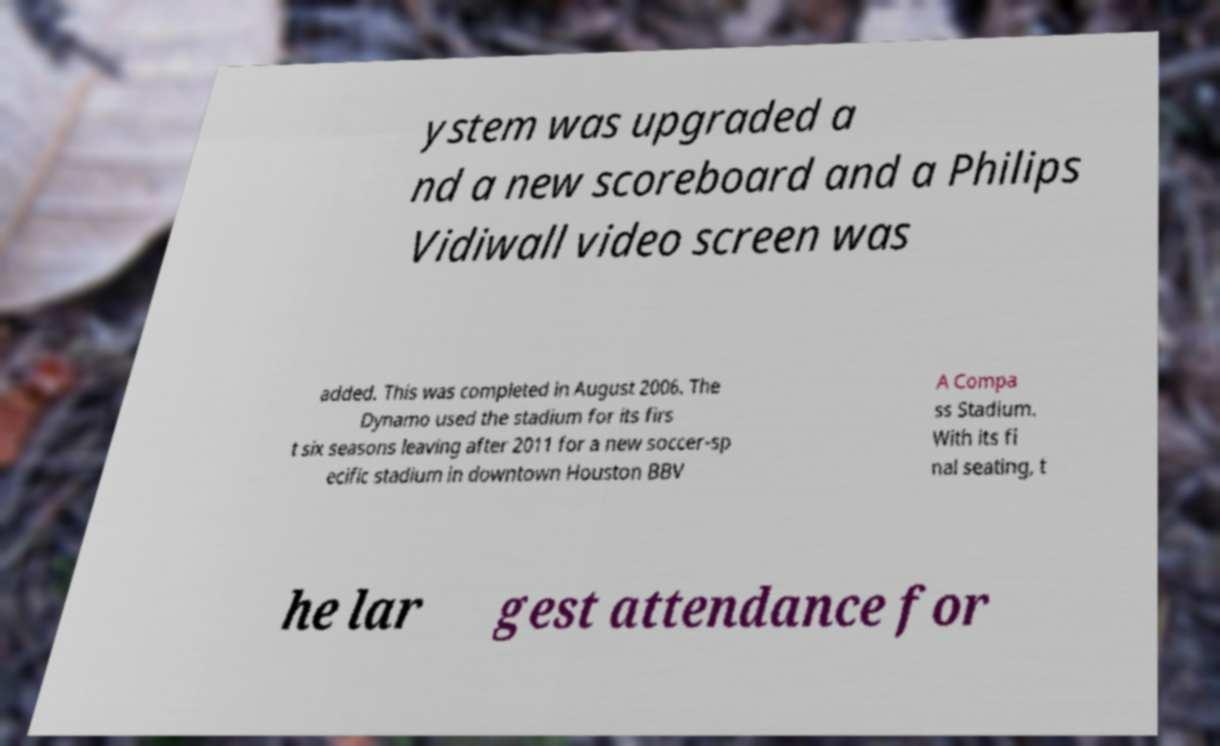Can you read and provide the text displayed in the image?This photo seems to have some interesting text. Can you extract and type it out for me? ystem was upgraded a nd a new scoreboard and a Philips Vidiwall video screen was added. This was completed in August 2006. The Dynamo used the stadium for its firs t six seasons leaving after 2011 for a new soccer-sp ecific stadium in downtown Houston BBV A Compa ss Stadium. With its fi nal seating, t he lar gest attendance for 